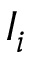Convert formula to latex. <formula><loc_0><loc_0><loc_500><loc_500>I _ { i }</formula> 